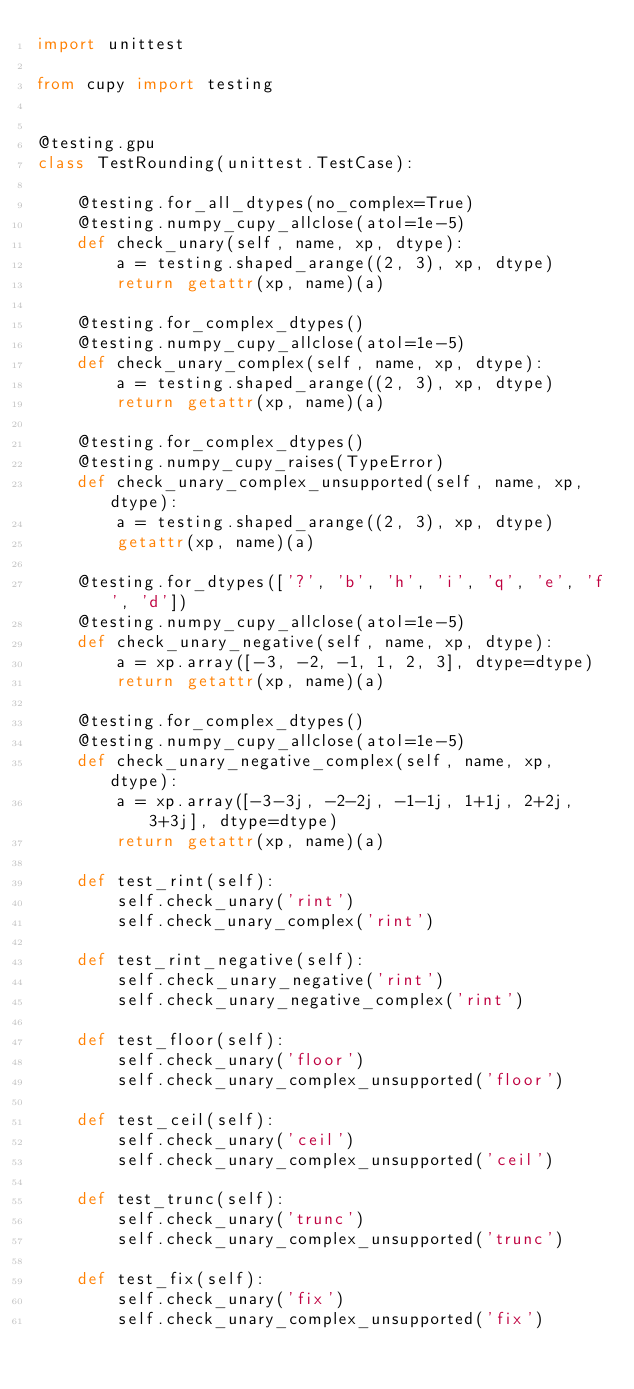Convert code to text. <code><loc_0><loc_0><loc_500><loc_500><_Python_>import unittest

from cupy import testing


@testing.gpu
class TestRounding(unittest.TestCase):

    @testing.for_all_dtypes(no_complex=True)
    @testing.numpy_cupy_allclose(atol=1e-5)
    def check_unary(self, name, xp, dtype):
        a = testing.shaped_arange((2, 3), xp, dtype)
        return getattr(xp, name)(a)

    @testing.for_complex_dtypes()
    @testing.numpy_cupy_allclose(atol=1e-5)
    def check_unary_complex(self, name, xp, dtype):
        a = testing.shaped_arange((2, 3), xp, dtype)
        return getattr(xp, name)(a)

    @testing.for_complex_dtypes()
    @testing.numpy_cupy_raises(TypeError)
    def check_unary_complex_unsupported(self, name, xp, dtype):
        a = testing.shaped_arange((2, 3), xp, dtype)
        getattr(xp, name)(a)

    @testing.for_dtypes(['?', 'b', 'h', 'i', 'q', 'e', 'f', 'd'])
    @testing.numpy_cupy_allclose(atol=1e-5)
    def check_unary_negative(self, name, xp, dtype):
        a = xp.array([-3, -2, -1, 1, 2, 3], dtype=dtype)
        return getattr(xp, name)(a)

    @testing.for_complex_dtypes()
    @testing.numpy_cupy_allclose(atol=1e-5)
    def check_unary_negative_complex(self, name, xp, dtype):
        a = xp.array([-3-3j, -2-2j, -1-1j, 1+1j, 2+2j, 3+3j], dtype=dtype)
        return getattr(xp, name)(a)

    def test_rint(self):
        self.check_unary('rint')
        self.check_unary_complex('rint')

    def test_rint_negative(self):
        self.check_unary_negative('rint')
        self.check_unary_negative_complex('rint')

    def test_floor(self):
        self.check_unary('floor')
        self.check_unary_complex_unsupported('floor')

    def test_ceil(self):
        self.check_unary('ceil')
        self.check_unary_complex_unsupported('ceil')

    def test_trunc(self):
        self.check_unary('trunc')
        self.check_unary_complex_unsupported('trunc')

    def test_fix(self):
        self.check_unary('fix')
        self.check_unary_complex_unsupported('fix')
</code> 